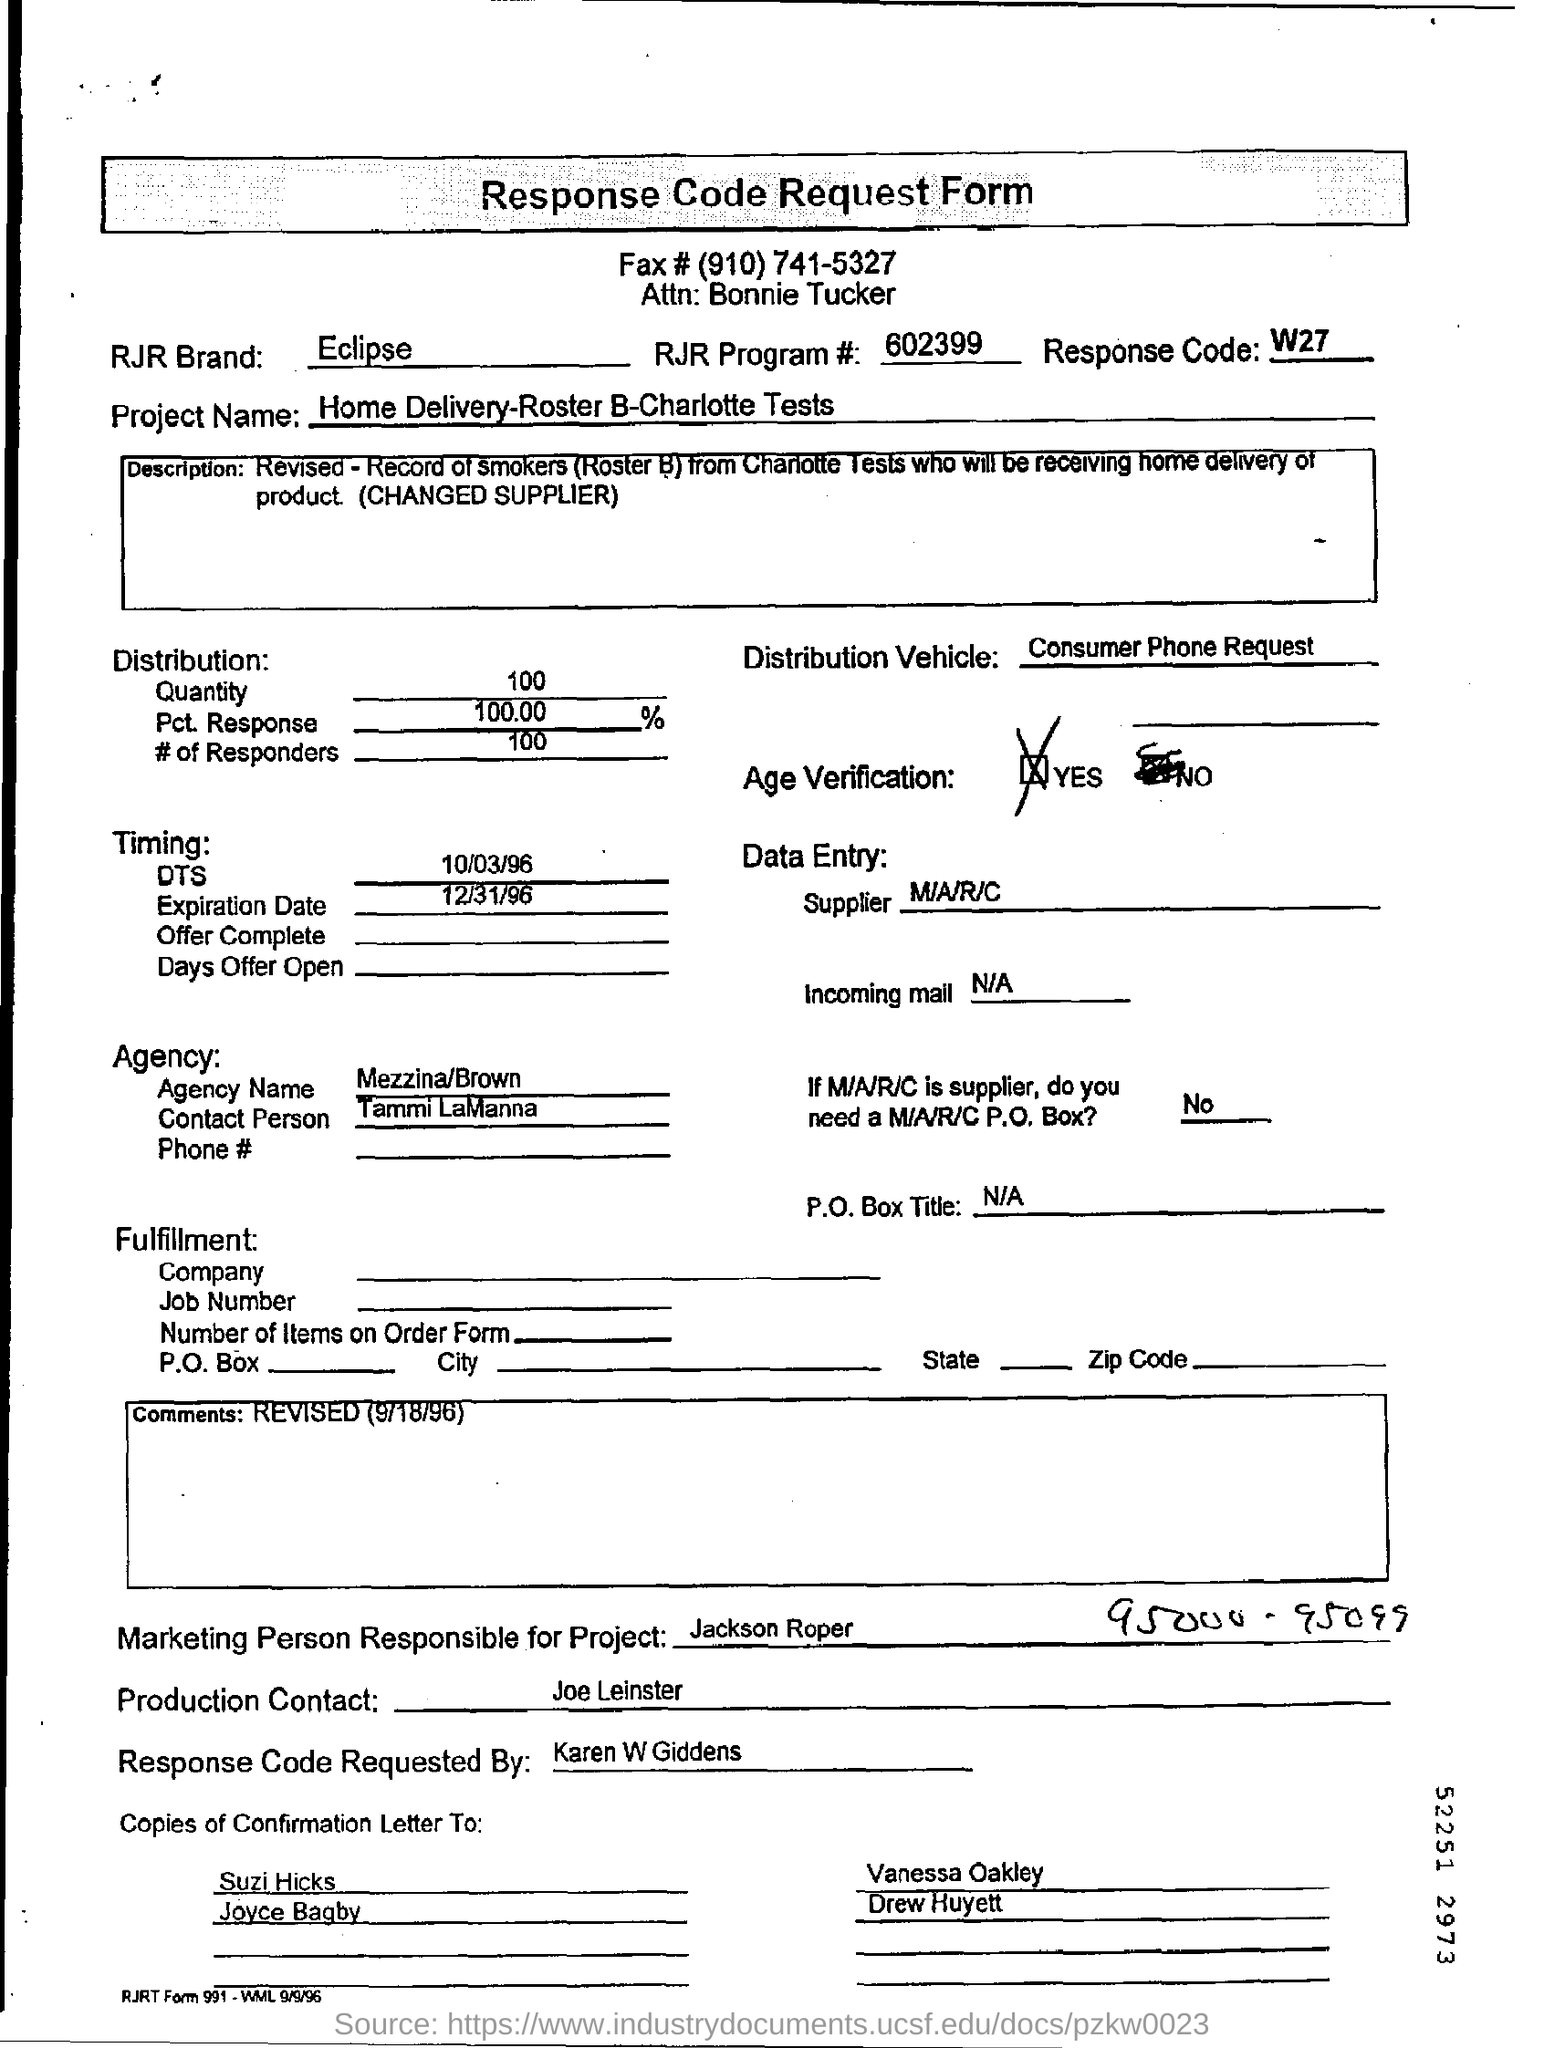What is the heading of the document?
Provide a short and direct response. Response Code Request Form. What is the RJR Brand?
Provide a short and direct response. Eclipse. What is in the Distribution Vehicle?
Keep it short and to the point. Consumer Phone Request. By whom is the Response Code Requested here?
Ensure brevity in your answer.  Karen W Giddens. 